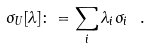Convert formula to latex. <formula><loc_0><loc_0><loc_500><loc_500>\sigma _ { U } [ \lambda ] \colon = \sum _ { i } \lambda _ { i } \sigma _ { i } \ .</formula> 